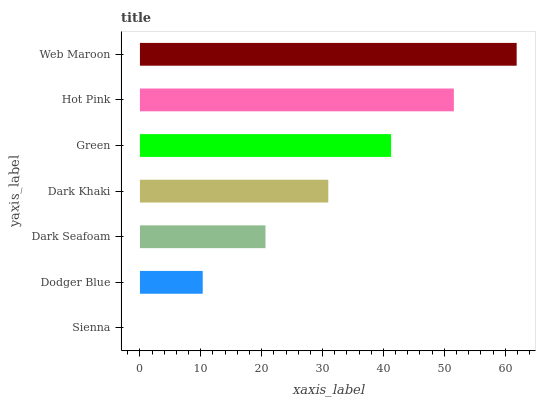Is Sienna the minimum?
Answer yes or no. Yes. Is Web Maroon the maximum?
Answer yes or no. Yes. Is Dodger Blue the minimum?
Answer yes or no. No. Is Dodger Blue the maximum?
Answer yes or no. No. Is Dodger Blue greater than Sienna?
Answer yes or no. Yes. Is Sienna less than Dodger Blue?
Answer yes or no. Yes. Is Sienna greater than Dodger Blue?
Answer yes or no. No. Is Dodger Blue less than Sienna?
Answer yes or no. No. Is Dark Khaki the high median?
Answer yes or no. Yes. Is Dark Khaki the low median?
Answer yes or no. Yes. Is Dodger Blue the high median?
Answer yes or no. No. Is Sienna the low median?
Answer yes or no. No. 